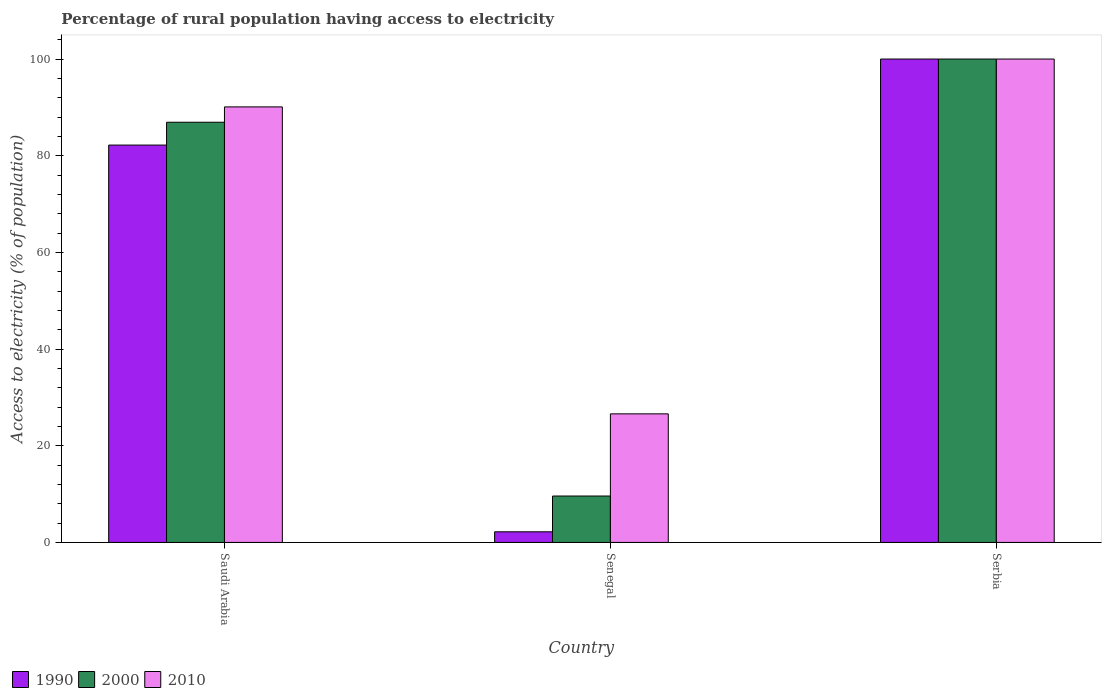How many groups of bars are there?
Make the answer very short. 3. Are the number of bars per tick equal to the number of legend labels?
Your answer should be very brief. Yes. Are the number of bars on each tick of the X-axis equal?
Make the answer very short. Yes. How many bars are there on the 2nd tick from the left?
Keep it short and to the point. 3. What is the label of the 2nd group of bars from the left?
Keep it short and to the point. Senegal. In how many cases, is the number of bars for a given country not equal to the number of legend labels?
Offer a terse response. 0. Across all countries, what is the maximum percentage of rural population having access to electricity in 2010?
Your answer should be very brief. 100. Across all countries, what is the minimum percentage of rural population having access to electricity in 2000?
Make the answer very short. 9.6. In which country was the percentage of rural population having access to electricity in 2000 maximum?
Provide a short and direct response. Serbia. In which country was the percentage of rural population having access to electricity in 2010 minimum?
Your answer should be compact. Senegal. What is the total percentage of rural population having access to electricity in 1990 in the graph?
Provide a succinct answer. 184.4. What is the difference between the percentage of rural population having access to electricity in 2010 in Senegal and that in Serbia?
Make the answer very short. -73.4. What is the difference between the percentage of rural population having access to electricity in 1990 in Saudi Arabia and the percentage of rural population having access to electricity in 2010 in Senegal?
Provide a short and direct response. 55.6. What is the average percentage of rural population having access to electricity in 2000 per country?
Give a very brief answer. 65.51. What is the difference between the percentage of rural population having access to electricity of/in 2000 and percentage of rural population having access to electricity of/in 2010 in Serbia?
Your response must be concise. 0. What is the ratio of the percentage of rural population having access to electricity in 2000 in Saudi Arabia to that in Serbia?
Ensure brevity in your answer.  0.87. What is the difference between the highest and the second highest percentage of rural population having access to electricity in 1990?
Keep it short and to the point. 80. What is the difference between the highest and the lowest percentage of rural population having access to electricity in 2000?
Make the answer very short. 90.4. What does the 1st bar from the left in Saudi Arabia represents?
Your answer should be compact. 1990. Is it the case that in every country, the sum of the percentage of rural population having access to electricity in 1990 and percentage of rural population having access to electricity in 2000 is greater than the percentage of rural population having access to electricity in 2010?
Keep it short and to the point. No. How many bars are there?
Keep it short and to the point. 9. Are all the bars in the graph horizontal?
Offer a terse response. No. How many countries are there in the graph?
Offer a terse response. 3. Are the values on the major ticks of Y-axis written in scientific E-notation?
Keep it short and to the point. No. Does the graph contain any zero values?
Provide a short and direct response. No. Does the graph contain grids?
Your answer should be compact. No. What is the title of the graph?
Provide a succinct answer. Percentage of rural population having access to electricity. What is the label or title of the X-axis?
Give a very brief answer. Country. What is the label or title of the Y-axis?
Keep it short and to the point. Access to electricity (% of population). What is the Access to electricity (% of population) of 1990 in Saudi Arabia?
Your response must be concise. 82.2. What is the Access to electricity (% of population) of 2000 in Saudi Arabia?
Provide a short and direct response. 86.93. What is the Access to electricity (% of population) of 2010 in Saudi Arabia?
Your answer should be very brief. 90.1. What is the Access to electricity (% of population) in 2000 in Senegal?
Your answer should be compact. 9.6. What is the Access to electricity (% of population) in 2010 in Senegal?
Offer a terse response. 26.6. What is the Access to electricity (% of population) in 2000 in Serbia?
Keep it short and to the point. 100. What is the Access to electricity (% of population) in 2010 in Serbia?
Offer a very short reply. 100. Across all countries, what is the maximum Access to electricity (% of population) in 1990?
Keep it short and to the point. 100. Across all countries, what is the maximum Access to electricity (% of population) of 2000?
Give a very brief answer. 100. Across all countries, what is the maximum Access to electricity (% of population) in 2010?
Keep it short and to the point. 100. Across all countries, what is the minimum Access to electricity (% of population) in 1990?
Keep it short and to the point. 2.2. Across all countries, what is the minimum Access to electricity (% of population) of 2010?
Offer a very short reply. 26.6. What is the total Access to electricity (% of population) in 1990 in the graph?
Make the answer very short. 184.4. What is the total Access to electricity (% of population) of 2000 in the graph?
Offer a very short reply. 196.53. What is the total Access to electricity (% of population) of 2010 in the graph?
Your answer should be compact. 216.7. What is the difference between the Access to electricity (% of population) of 1990 in Saudi Arabia and that in Senegal?
Offer a very short reply. 80. What is the difference between the Access to electricity (% of population) in 2000 in Saudi Arabia and that in Senegal?
Provide a succinct answer. 77.33. What is the difference between the Access to electricity (% of population) in 2010 in Saudi Arabia and that in Senegal?
Offer a terse response. 63.5. What is the difference between the Access to electricity (% of population) of 1990 in Saudi Arabia and that in Serbia?
Give a very brief answer. -17.8. What is the difference between the Access to electricity (% of population) in 2000 in Saudi Arabia and that in Serbia?
Your response must be concise. -13.07. What is the difference between the Access to electricity (% of population) of 2010 in Saudi Arabia and that in Serbia?
Your response must be concise. -9.9. What is the difference between the Access to electricity (% of population) in 1990 in Senegal and that in Serbia?
Provide a succinct answer. -97.8. What is the difference between the Access to electricity (% of population) in 2000 in Senegal and that in Serbia?
Your response must be concise. -90.4. What is the difference between the Access to electricity (% of population) in 2010 in Senegal and that in Serbia?
Offer a very short reply. -73.4. What is the difference between the Access to electricity (% of population) of 1990 in Saudi Arabia and the Access to electricity (% of population) of 2000 in Senegal?
Ensure brevity in your answer.  72.6. What is the difference between the Access to electricity (% of population) of 1990 in Saudi Arabia and the Access to electricity (% of population) of 2010 in Senegal?
Make the answer very short. 55.6. What is the difference between the Access to electricity (% of population) in 2000 in Saudi Arabia and the Access to electricity (% of population) in 2010 in Senegal?
Keep it short and to the point. 60.33. What is the difference between the Access to electricity (% of population) in 1990 in Saudi Arabia and the Access to electricity (% of population) in 2000 in Serbia?
Give a very brief answer. -17.8. What is the difference between the Access to electricity (% of population) of 1990 in Saudi Arabia and the Access to electricity (% of population) of 2010 in Serbia?
Your response must be concise. -17.8. What is the difference between the Access to electricity (% of population) of 2000 in Saudi Arabia and the Access to electricity (% of population) of 2010 in Serbia?
Your answer should be compact. -13.07. What is the difference between the Access to electricity (% of population) in 1990 in Senegal and the Access to electricity (% of population) in 2000 in Serbia?
Your answer should be compact. -97.8. What is the difference between the Access to electricity (% of population) of 1990 in Senegal and the Access to electricity (% of population) of 2010 in Serbia?
Provide a succinct answer. -97.8. What is the difference between the Access to electricity (% of population) in 2000 in Senegal and the Access to electricity (% of population) in 2010 in Serbia?
Give a very brief answer. -90.4. What is the average Access to electricity (% of population) of 1990 per country?
Your answer should be compact. 61.47. What is the average Access to electricity (% of population) of 2000 per country?
Your response must be concise. 65.51. What is the average Access to electricity (% of population) in 2010 per country?
Keep it short and to the point. 72.23. What is the difference between the Access to electricity (% of population) of 1990 and Access to electricity (% of population) of 2000 in Saudi Arabia?
Give a very brief answer. -4.72. What is the difference between the Access to electricity (% of population) of 1990 and Access to electricity (% of population) of 2010 in Saudi Arabia?
Your response must be concise. -7.9. What is the difference between the Access to electricity (% of population) of 2000 and Access to electricity (% of population) of 2010 in Saudi Arabia?
Ensure brevity in your answer.  -3.17. What is the difference between the Access to electricity (% of population) of 1990 and Access to electricity (% of population) of 2010 in Senegal?
Your answer should be very brief. -24.4. What is the difference between the Access to electricity (% of population) of 2000 and Access to electricity (% of population) of 2010 in Serbia?
Give a very brief answer. 0. What is the ratio of the Access to electricity (% of population) of 1990 in Saudi Arabia to that in Senegal?
Give a very brief answer. 37.37. What is the ratio of the Access to electricity (% of population) of 2000 in Saudi Arabia to that in Senegal?
Make the answer very short. 9.05. What is the ratio of the Access to electricity (% of population) of 2010 in Saudi Arabia to that in Senegal?
Provide a succinct answer. 3.39. What is the ratio of the Access to electricity (% of population) in 1990 in Saudi Arabia to that in Serbia?
Provide a short and direct response. 0.82. What is the ratio of the Access to electricity (% of population) of 2000 in Saudi Arabia to that in Serbia?
Offer a terse response. 0.87. What is the ratio of the Access to electricity (% of population) of 2010 in Saudi Arabia to that in Serbia?
Provide a succinct answer. 0.9. What is the ratio of the Access to electricity (% of population) of 1990 in Senegal to that in Serbia?
Make the answer very short. 0.02. What is the ratio of the Access to electricity (% of population) of 2000 in Senegal to that in Serbia?
Keep it short and to the point. 0.1. What is the ratio of the Access to electricity (% of population) in 2010 in Senegal to that in Serbia?
Offer a very short reply. 0.27. What is the difference between the highest and the second highest Access to electricity (% of population) of 1990?
Your answer should be compact. 17.8. What is the difference between the highest and the second highest Access to electricity (% of population) in 2000?
Provide a succinct answer. 13.07. What is the difference between the highest and the second highest Access to electricity (% of population) in 2010?
Your answer should be very brief. 9.9. What is the difference between the highest and the lowest Access to electricity (% of population) in 1990?
Offer a very short reply. 97.8. What is the difference between the highest and the lowest Access to electricity (% of population) in 2000?
Provide a short and direct response. 90.4. What is the difference between the highest and the lowest Access to electricity (% of population) of 2010?
Ensure brevity in your answer.  73.4. 